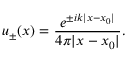<formula> <loc_0><loc_0><loc_500><loc_500>u _ { \pm } ( x ) = { \frac { e ^ { \pm i k | x - x _ { 0 } | } } { 4 \pi | x - x _ { 0 } | } } .</formula> 